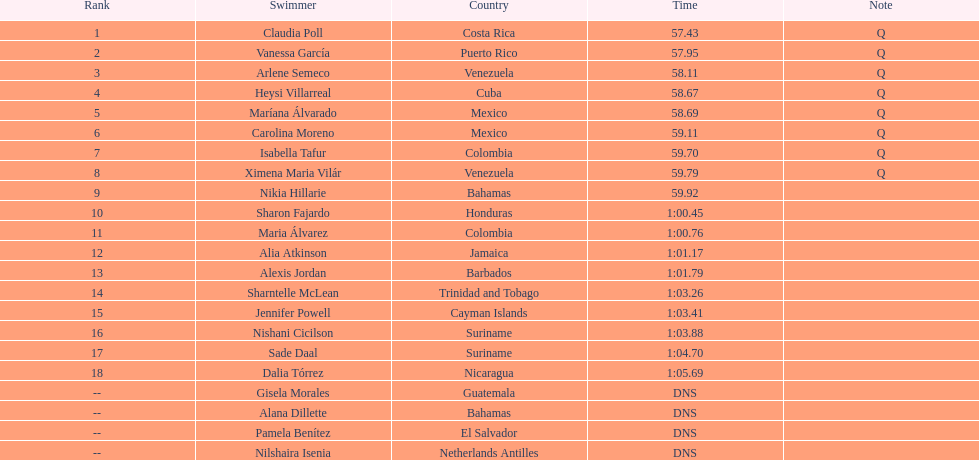Which swimmer held the highest or premier position? Claudia Poll. 